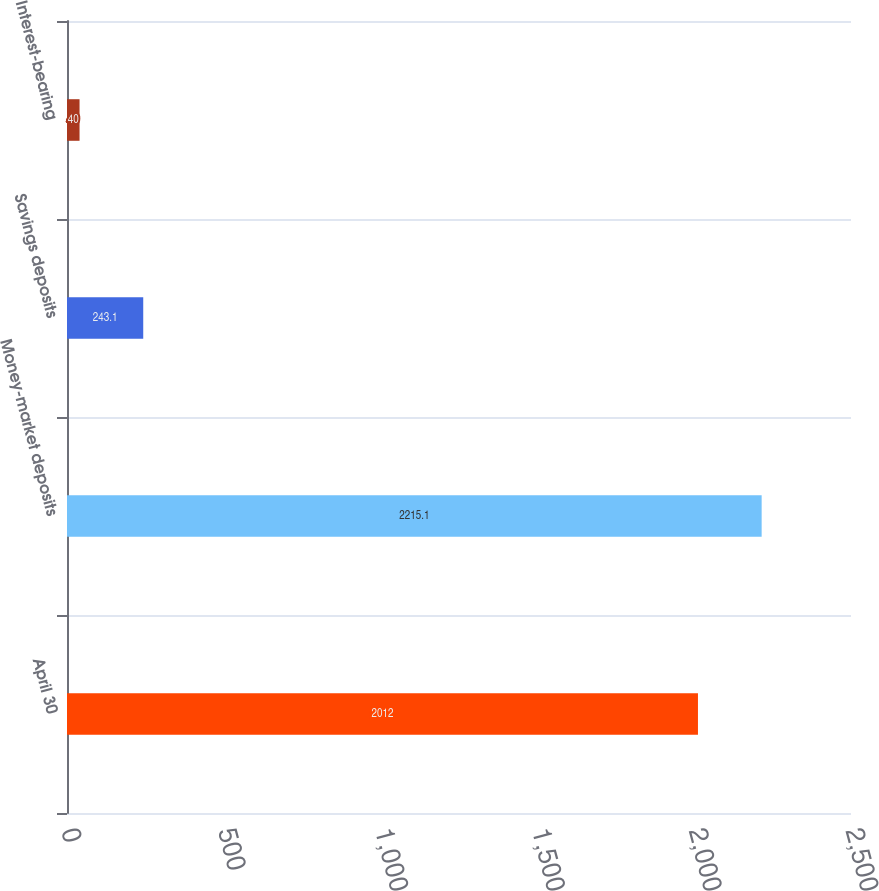Convert chart to OTSL. <chart><loc_0><loc_0><loc_500><loc_500><bar_chart><fcel>April 30<fcel>Money-market deposits<fcel>Savings deposits<fcel>Interest-bearing<nl><fcel>2012<fcel>2215.1<fcel>243.1<fcel>40<nl></chart> 